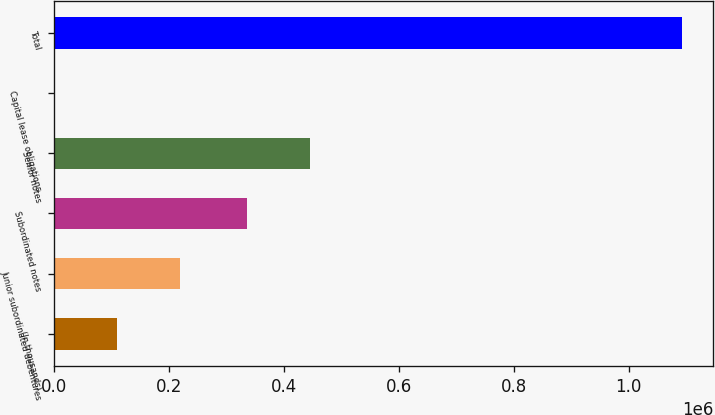<chart> <loc_0><loc_0><loc_500><loc_500><bar_chart><fcel>(In thousands)<fcel>Junior subordinated debentures<fcel>Subordinated notes<fcel>Senior notes<fcel>Capital lease obligations<fcel>Total<nl><fcel>110184<fcel>219306<fcel>335798<fcel>444920<fcel>1062<fcel>1.09228e+06<nl></chart> 